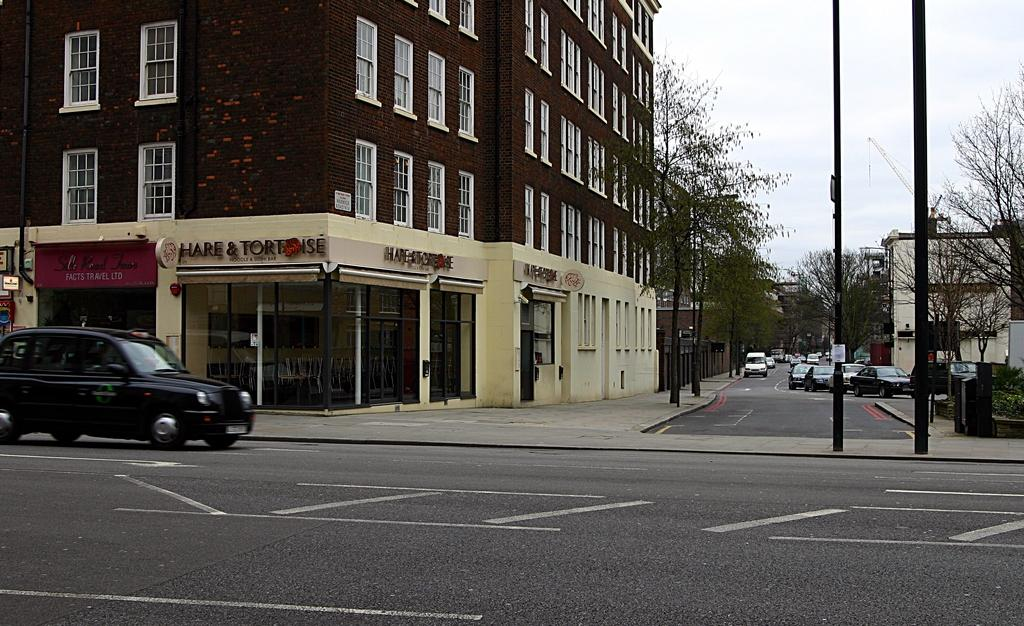<image>
Write a terse but informative summary of the picture. A restaurant called Hare and Tortoise sits on a street corner 